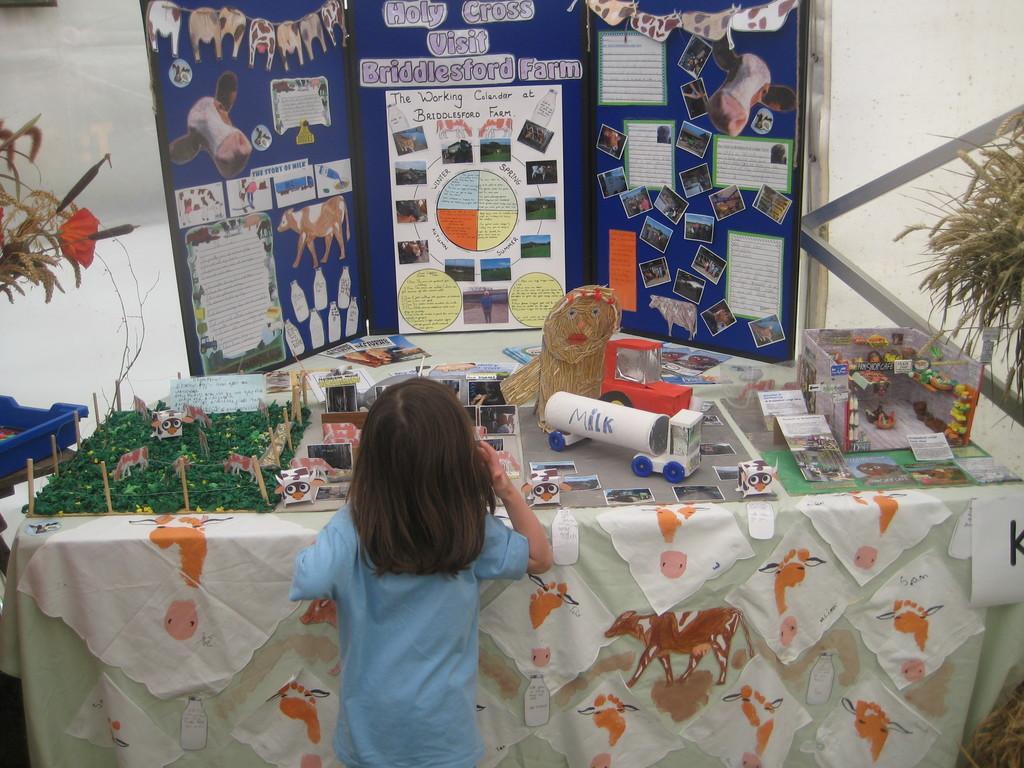Can you describe this image briefly? A girl is watching crafts kept on a table. 